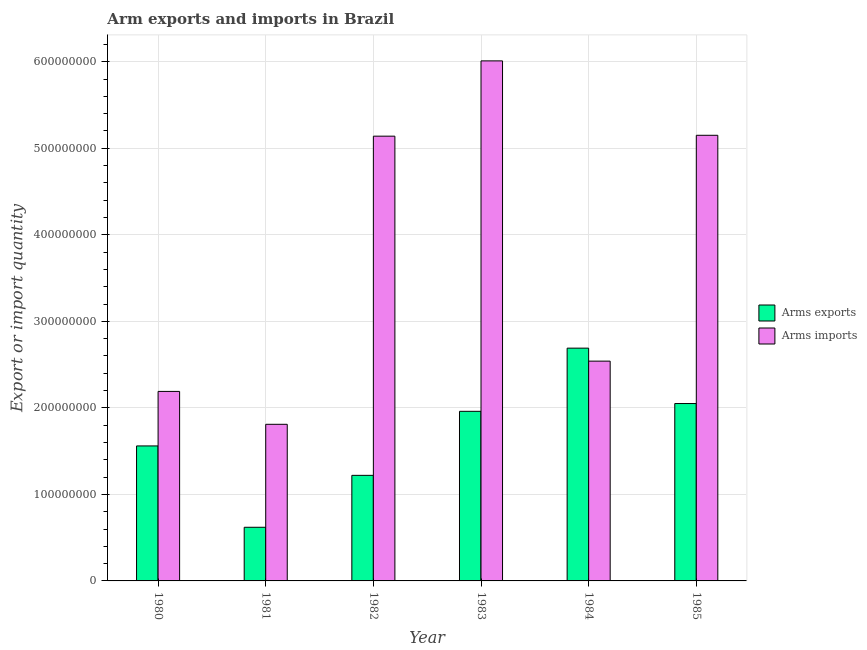How many different coloured bars are there?
Keep it short and to the point. 2. How many groups of bars are there?
Make the answer very short. 6. Are the number of bars per tick equal to the number of legend labels?
Ensure brevity in your answer.  Yes. Are the number of bars on each tick of the X-axis equal?
Your answer should be compact. Yes. How many bars are there on the 2nd tick from the right?
Make the answer very short. 2. What is the label of the 5th group of bars from the left?
Make the answer very short. 1984. In how many cases, is the number of bars for a given year not equal to the number of legend labels?
Give a very brief answer. 0. What is the arms exports in 1982?
Keep it short and to the point. 1.22e+08. Across all years, what is the maximum arms exports?
Offer a terse response. 2.69e+08. Across all years, what is the minimum arms imports?
Your response must be concise. 1.81e+08. In which year was the arms imports minimum?
Your answer should be very brief. 1981. What is the total arms exports in the graph?
Provide a succinct answer. 1.01e+09. What is the difference between the arms imports in 1982 and that in 1983?
Provide a short and direct response. -8.70e+07. What is the difference between the arms imports in 1981 and the arms exports in 1982?
Your response must be concise. -3.33e+08. What is the average arms exports per year?
Keep it short and to the point. 1.68e+08. What is the ratio of the arms imports in 1980 to that in 1983?
Offer a terse response. 0.36. What is the difference between the highest and the second highest arms imports?
Give a very brief answer. 8.60e+07. What is the difference between the highest and the lowest arms imports?
Your answer should be compact. 4.20e+08. What does the 2nd bar from the left in 1984 represents?
Provide a succinct answer. Arms imports. What does the 1st bar from the right in 1981 represents?
Provide a succinct answer. Arms imports. How many bars are there?
Make the answer very short. 12. Are all the bars in the graph horizontal?
Provide a succinct answer. No. How many years are there in the graph?
Offer a terse response. 6. What is the difference between two consecutive major ticks on the Y-axis?
Your answer should be compact. 1.00e+08. Does the graph contain any zero values?
Your answer should be very brief. No. How many legend labels are there?
Provide a short and direct response. 2. What is the title of the graph?
Your response must be concise. Arm exports and imports in Brazil. What is the label or title of the Y-axis?
Offer a terse response. Export or import quantity. What is the Export or import quantity of Arms exports in 1980?
Ensure brevity in your answer.  1.56e+08. What is the Export or import quantity in Arms imports in 1980?
Your answer should be very brief. 2.19e+08. What is the Export or import quantity of Arms exports in 1981?
Provide a succinct answer. 6.20e+07. What is the Export or import quantity of Arms imports in 1981?
Offer a terse response. 1.81e+08. What is the Export or import quantity of Arms exports in 1982?
Keep it short and to the point. 1.22e+08. What is the Export or import quantity in Arms imports in 1982?
Ensure brevity in your answer.  5.14e+08. What is the Export or import quantity of Arms exports in 1983?
Make the answer very short. 1.96e+08. What is the Export or import quantity in Arms imports in 1983?
Provide a succinct answer. 6.01e+08. What is the Export or import quantity in Arms exports in 1984?
Provide a succinct answer. 2.69e+08. What is the Export or import quantity in Arms imports in 1984?
Offer a very short reply. 2.54e+08. What is the Export or import quantity in Arms exports in 1985?
Your answer should be very brief. 2.05e+08. What is the Export or import quantity of Arms imports in 1985?
Ensure brevity in your answer.  5.15e+08. Across all years, what is the maximum Export or import quantity in Arms exports?
Your answer should be very brief. 2.69e+08. Across all years, what is the maximum Export or import quantity in Arms imports?
Provide a succinct answer. 6.01e+08. Across all years, what is the minimum Export or import quantity in Arms exports?
Your answer should be compact. 6.20e+07. Across all years, what is the minimum Export or import quantity of Arms imports?
Your answer should be compact. 1.81e+08. What is the total Export or import quantity in Arms exports in the graph?
Offer a terse response. 1.01e+09. What is the total Export or import quantity of Arms imports in the graph?
Offer a very short reply. 2.28e+09. What is the difference between the Export or import quantity of Arms exports in 1980 and that in 1981?
Ensure brevity in your answer.  9.40e+07. What is the difference between the Export or import quantity in Arms imports in 1980 and that in 1981?
Offer a very short reply. 3.80e+07. What is the difference between the Export or import quantity of Arms exports in 1980 and that in 1982?
Your response must be concise. 3.40e+07. What is the difference between the Export or import quantity of Arms imports in 1980 and that in 1982?
Your response must be concise. -2.95e+08. What is the difference between the Export or import quantity in Arms exports in 1980 and that in 1983?
Provide a succinct answer. -4.00e+07. What is the difference between the Export or import quantity in Arms imports in 1980 and that in 1983?
Ensure brevity in your answer.  -3.82e+08. What is the difference between the Export or import quantity in Arms exports in 1980 and that in 1984?
Ensure brevity in your answer.  -1.13e+08. What is the difference between the Export or import quantity of Arms imports in 1980 and that in 1984?
Provide a short and direct response. -3.50e+07. What is the difference between the Export or import quantity of Arms exports in 1980 and that in 1985?
Provide a short and direct response. -4.90e+07. What is the difference between the Export or import quantity in Arms imports in 1980 and that in 1985?
Make the answer very short. -2.96e+08. What is the difference between the Export or import quantity in Arms exports in 1981 and that in 1982?
Ensure brevity in your answer.  -6.00e+07. What is the difference between the Export or import quantity in Arms imports in 1981 and that in 1982?
Make the answer very short. -3.33e+08. What is the difference between the Export or import quantity of Arms exports in 1981 and that in 1983?
Ensure brevity in your answer.  -1.34e+08. What is the difference between the Export or import quantity in Arms imports in 1981 and that in 1983?
Give a very brief answer. -4.20e+08. What is the difference between the Export or import quantity of Arms exports in 1981 and that in 1984?
Your answer should be compact. -2.07e+08. What is the difference between the Export or import quantity of Arms imports in 1981 and that in 1984?
Offer a very short reply. -7.30e+07. What is the difference between the Export or import quantity in Arms exports in 1981 and that in 1985?
Offer a very short reply. -1.43e+08. What is the difference between the Export or import quantity of Arms imports in 1981 and that in 1985?
Make the answer very short. -3.34e+08. What is the difference between the Export or import quantity in Arms exports in 1982 and that in 1983?
Give a very brief answer. -7.40e+07. What is the difference between the Export or import quantity in Arms imports in 1982 and that in 1983?
Your answer should be compact. -8.70e+07. What is the difference between the Export or import quantity in Arms exports in 1982 and that in 1984?
Offer a very short reply. -1.47e+08. What is the difference between the Export or import quantity of Arms imports in 1982 and that in 1984?
Your answer should be compact. 2.60e+08. What is the difference between the Export or import quantity of Arms exports in 1982 and that in 1985?
Provide a succinct answer. -8.30e+07. What is the difference between the Export or import quantity in Arms exports in 1983 and that in 1984?
Give a very brief answer. -7.30e+07. What is the difference between the Export or import quantity of Arms imports in 1983 and that in 1984?
Make the answer very short. 3.47e+08. What is the difference between the Export or import quantity in Arms exports in 1983 and that in 1985?
Ensure brevity in your answer.  -9.00e+06. What is the difference between the Export or import quantity in Arms imports in 1983 and that in 1985?
Provide a short and direct response. 8.60e+07. What is the difference between the Export or import quantity in Arms exports in 1984 and that in 1985?
Offer a very short reply. 6.40e+07. What is the difference between the Export or import quantity of Arms imports in 1984 and that in 1985?
Your answer should be compact. -2.61e+08. What is the difference between the Export or import quantity of Arms exports in 1980 and the Export or import quantity of Arms imports in 1981?
Offer a terse response. -2.50e+07. What is the difference between the Export or import quantity of Arms exports in 1980 and the Export or import quantity of Arms imports in 1982?
Your answer should be very brief. -3.58e+08. What is the difference between the Export or import quantity of Arms exports in 1980 and the Export or import quantity of Arms imports in 1983?
Make the answer very short. -4.45e+08. What is the difference between the Export or import quantity in Arms exports in 1980 and the Export or import quantity in Arms imports in 1984?
Give a very brief answer. -9.80e+07. What is the difference between the Export or import quantity of Arms exports in 1980 and the Export or import quantity of Arms imports in 1985?
Your answer should be very brief. -3.59e+08. What is the difference between the Export or import quantity in Arms exports in 1981 and the Export or import quantity in Arms imports in 1982?
Give a very brief answer. -4.52e+08. What is the difference between the Export or import quantity of Arms exports in 1981 and the Export or import quantity of Arms imports in 1983?
Your answer should be compact. -5.39e+08. What is the difference between the Export or import quantity in Arms exports in 1981 and the Export or import quantity in Arms imports in 1984?
Keep it short and to the point. -1.92e+08. What is the difference between the Export or import quantity in Arms exports in 1981 and the Export or import quantity in Arms imports in 1985?
Your response must be concise. -4.53e+08. What is the difference between the Export or import quantity in Arms exports in 1982 and the Export or import quantity in Arms imports in 1983?
Your response must be concise. -4.79e+08. What is the difference between the Export or import quantity in Arms exports in 1982 and the Export or import quantity in Arms imports in 1984?
Offer a terse response. -1.32e+08. What is the difference between the Export or import quantity of Arms exports in 1982 and the Export or import quantity of Arms imports in 1985?
Give a very brief answer. -3.93e+08. What is the difference between the Export or import quantity of Arms exports in 1983 and the Export or import quantity of Arms imports in 1984?
Your response must be concise. -5.80e+07. What is the difference between the Export or import quantity in Arms exports in 1983 and the Export or import quantity in Arms imports in 1985?
Offer a very short reply. -3.19e+08. What is the difference between the Export or import quantity in Arms exports in 1984 and the Export or import quantity in Arms imports in 1985?
Your answer should be compact. -2.46e+08. What is the average Export or import quantity of Arms exports per year?
Offer a terse response. 1.68e+08. What is the average Export or import quantity in Arms imports per year?
Offer a very short reply. 3.81e+08. In the year 1980, what is the difference between the Export or import quantity in Arms exports and Export or import quantity in Arms imports?
Ensure brevity in your answer.  -6.30e+07. In the year 1981, what is the difference between the Export or import quantity in Arms exports and Export or import quantity in Arms imports?
Offer a terse response. -1.19e+08. In the year 1982, what is the difference between the Export or import quantity of Arms exports and Export or import quantity of Arms imports?
Your answer should be compact. -3.92e+08. In the year 1983, what is the difference between the Export or import quantity of Arms exports and Export or import quantity of Arms imports?
Provide a succinct answer. -4.05e+08. In the year 1984, what is the difference between the Export or import quantity of Arms exports and Export or import quantity of Arms imports?
Make the answer very short. 1.50e+07. In the year 1985, what is the difference between the Export or import quantity in Arms exports and Export or import quantity in Arms imports?
Provide a short and direct response. -3.10e+08. What is the ratio of the Export or import quantity of Arms exports in 1980 to that in 1981?
Keep it short and to the point. 2.52. What is the ratio of the Export or import quantity in Arms imports in 1980 to that in 1981?
Keep it short and to the point. 1.21. What is the ratio of the Export or import quantity of Arms exports in 1980 to that in 1982?
Give a very brief answer. 1.28. What is the ratio of the Export or import quantity in Arms imports in 1980 to that in 1982?
Provide a short and direct response. 0.43. What is the ratio of the Export or import quantity in Arms exports in 1980 to that in 1983?
Provide a short and direct response. 0.8. What is the ratio of the Export or import quantity of Arms imports in 1980 to that in 1983?
Make the answer very short. 0.36. What is the ratio of the Export or import quantity in Arms exports in 1980 to that in 1984?
Give a very brief answer. 0.58. What is the ratio of the Export or import quantity of Arms imports in 1980 to that in 1984?
Provide a short and direct response. 0.86. What is the ratio of the Export or import quantity of Arms exports in 1980 to that in 1985?
Provide a short and direct response. 0.76. What is the ratio of the Export or import quantity of Arms imports in 1980 to that in 1985?
Offer a very short reply. 0.43. What is the ratio of the Export or import quantity of Arms exports in 1981 to that in 1982?
Your response must be concise. 0.51. What is the ratio of the Export or import quantity of Arms imports in 1981 to that in 1982?
Provide a short and direct response. 0.35. What is the ratio of the Export or import quantity in Arms exports in 1981 to that in 1983?
Your response must be concise. 0.32. What is the ratio of the Export or import quantity of Arms imports in 1981 to that in 1983?
Provide a succinct answer. 0.3. What is the ratio of the Export or import quantity in Arms exports in 1981 to that in 1984?
Offer a terse response. 0.23. What is the ratio of the Export or import quantity in Arms imports in 1981 to that in 1984?
Provide a short and direct response. 0.71. What is the ratio of the Export or import quantity in Arms exports in 1981 to that in 1985?
Your answer should be compact. 0.3. What is the ratio of the Export or import quantity of Arms imports in 1981 to that in 1985?
Ensure brevity in your answer.  0.35. What is the ratio of the Export or import quantity in Arms exports in 1982 to that in 1983?
Make the answer very short. 0.62. What is the ratio of the Export or import quantity of Arms imports in 1982 to that in 1983?
Keep it short and to the point. 0.86. What is the ratio of the Export or import quantity of Arms exports in 1982 to that in 1984?
Your response must be concise. 0.45. What is the ratio of the Export or import quantity of Arms imports in 1982 to that in 1984?
Offer a terse response. 2.02. What is the ratio of the Export or import quantity in Arms exports in 1982 to that in 1985?
Keep it short and to the point. 0.6. What is the ratio of the Export or import quantity of Arms exports in 1983 to that in 1984?
Ensure brevity in your answer.  0.73. What is the ratio of the Export or import quantity in Arms imports in 1983 to that in 1984?
Your answer should be very brief. 2.37. What is the ratio of the Export or import quantity in Arms exports in 1983 to that in 1985?
Your answer should be compact. 0.96. What is the ratio of the Export or import quantity of Arms imports in 1983 to that in 1985?
Provide a succinct answer. 1.17. What is the ratio of the Export or import quantity in Arms exports in 1984 to that in 1985?
Provide a short and direct response. 1.31. What is the ratio of the Export or import quantity in Arms imports in 1984 to that in 1985?
Offer a terse response. 0.49. What is the difference between the highest and the second highest Export or import quantity of Arms exports?
Offer a terse response. 6.40e+07. What is the difference between the highest and the second highest Export or import quantity of Arms imports?
Your answer should be very brief. 8.60e+07. What is the difference between the highest and the lowest Export or import quantity of Arms exports?
Ensure brevity in your answer.  2.07e+08. What is the difference between the highest and the lowest Export or import quantity in Arms imports?
Offer a terse response. 4.20e+08. 